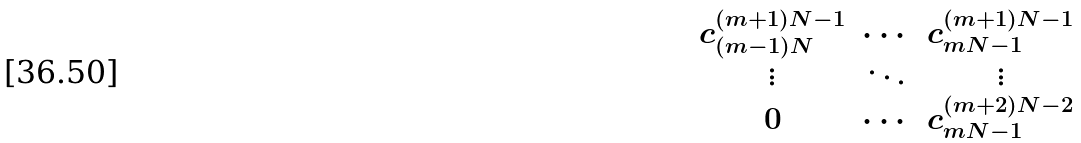Convert formula to latex. <formula><loc_0><loc_0><loc_500><loc_500>\begin{matrix} c ^ { ( m + 1 ) N - 1 } _ { ( m - 1 ) N } & \cdots & c ^ { ( m + 1 ) N - 1 } _ { m N - 1 } \\ \vdots & \ddots & \vdots \\ 0 & \cdots & c ^ { ( m + 2 ) N - 2 } _ { m N - 1 } \end{matrix}</formula> 